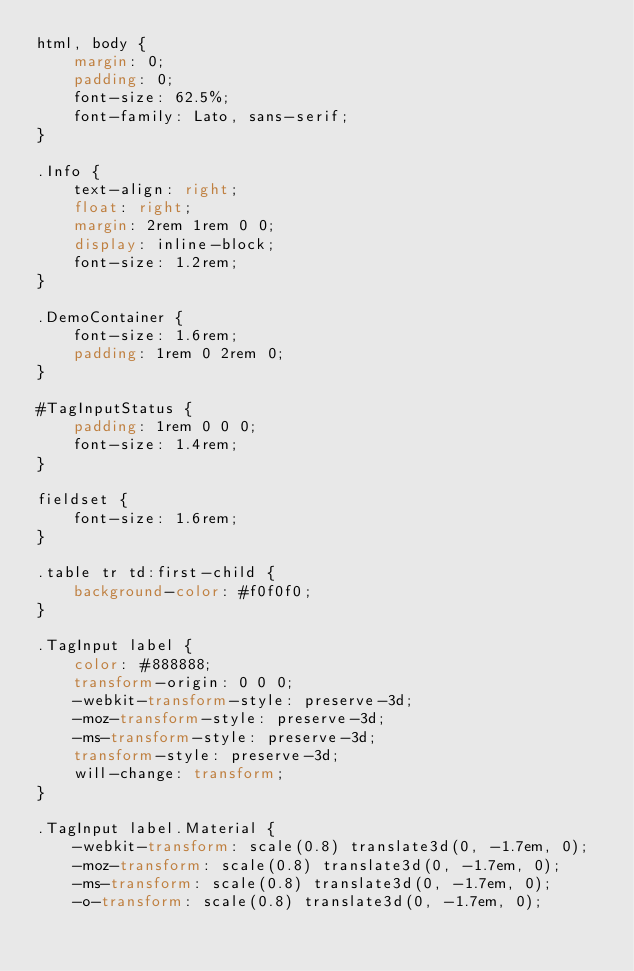<code> <loc_0><loc_0><loc_500><loc_500><_CSS_>html, body {
    margin: 0;
    padding: 0;
    font-size: 62.5%;
    font-family: Lato, sans-serif;
}

.Info {
    text-align: right;
    float: right;
    margin: 2rem 1rem 0 0;
    display: inline-block;
    font-size: 1.2rem;
}

.DemoContainer {
    font-size: 1.6rem;
    padding: 1rem 0 2rem 0;
}

#TagInputStatus {
    padding: 1rem 0 0 0;
    font-size: 1.4rem;
}

fieldset {
    font-size: 1.6rem;
}

.table tr td:first-child {
    background-color: #f0f0f0;
}

.TagInput label {
    color: #888888;
    transform-origin: 0 0 0;
    -webkit-transform-style: preserve-3d;
    -moz-transform-style: preserve-3d;
    -ms-transform-style: preserve-3d;
    transform-style: preserve-3d;
    will-change: transform;
}

.TagInput label.Material {
    -webkit-transform: scale(0.8) translate3d(0, -1.7em, 0);
    -moz-transform: scale(0.8) translate3d(0, -1.7em, 0);
    -ms-transform: scale(0.8) translate3d(0, -1.7em, 0);
    -o-transform: scale(0.8) translate3d(0, -1.7em, 0);</code> 